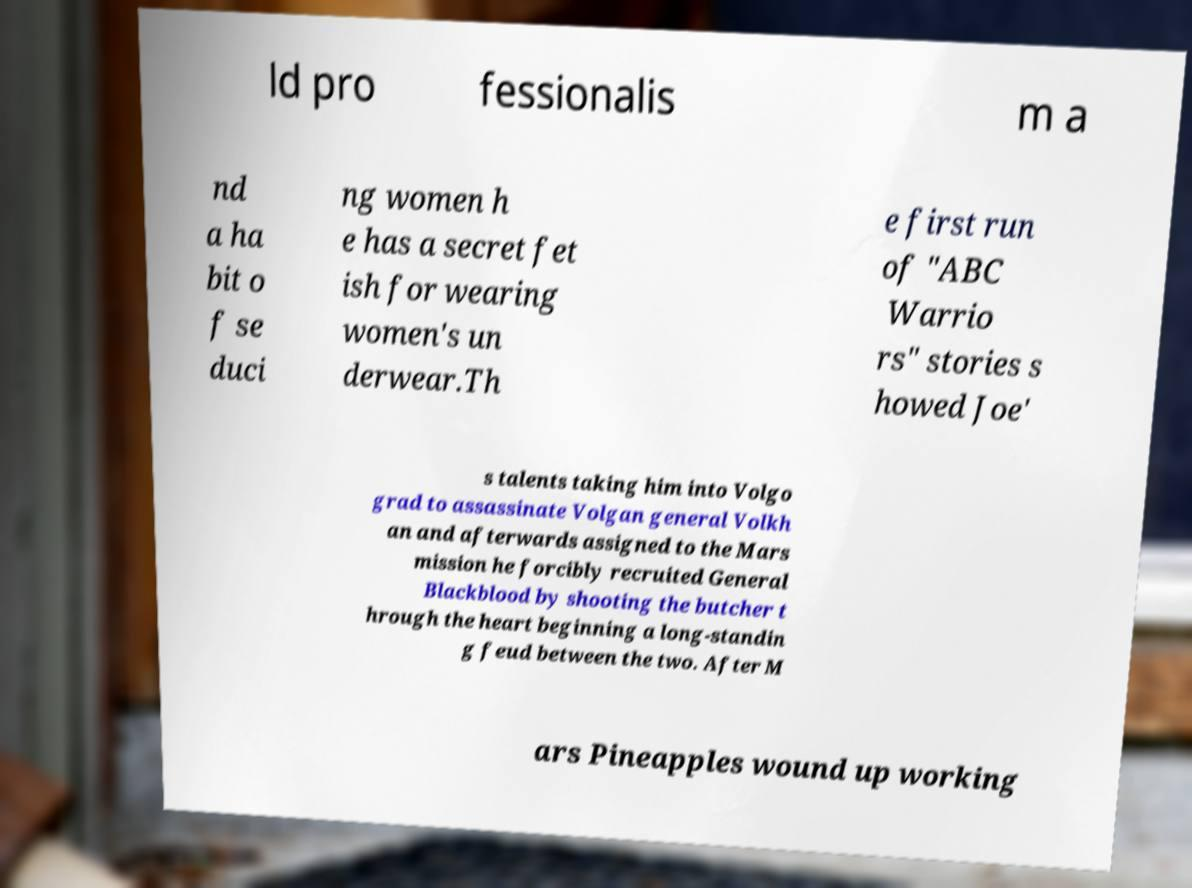There's text embedded in this image that I need extracted. Can you transcribe it verbatim? ld pro fessionalis m a nd a ha bit o f se duci ng women h e has a secret fet ish for wearing women's un derwear.Th e first run of "ABC Warrio rs" stories s howed Joe' s talents taking him into Volgo grad to assassinate Volgan general Volkh an and afterwards assigned to the Mars mission he forcibly recruited General Blackblood by shooting the butcher t hrough the heart beginning a long-standin g feud between the two. After M ars Pineapples wound up working 